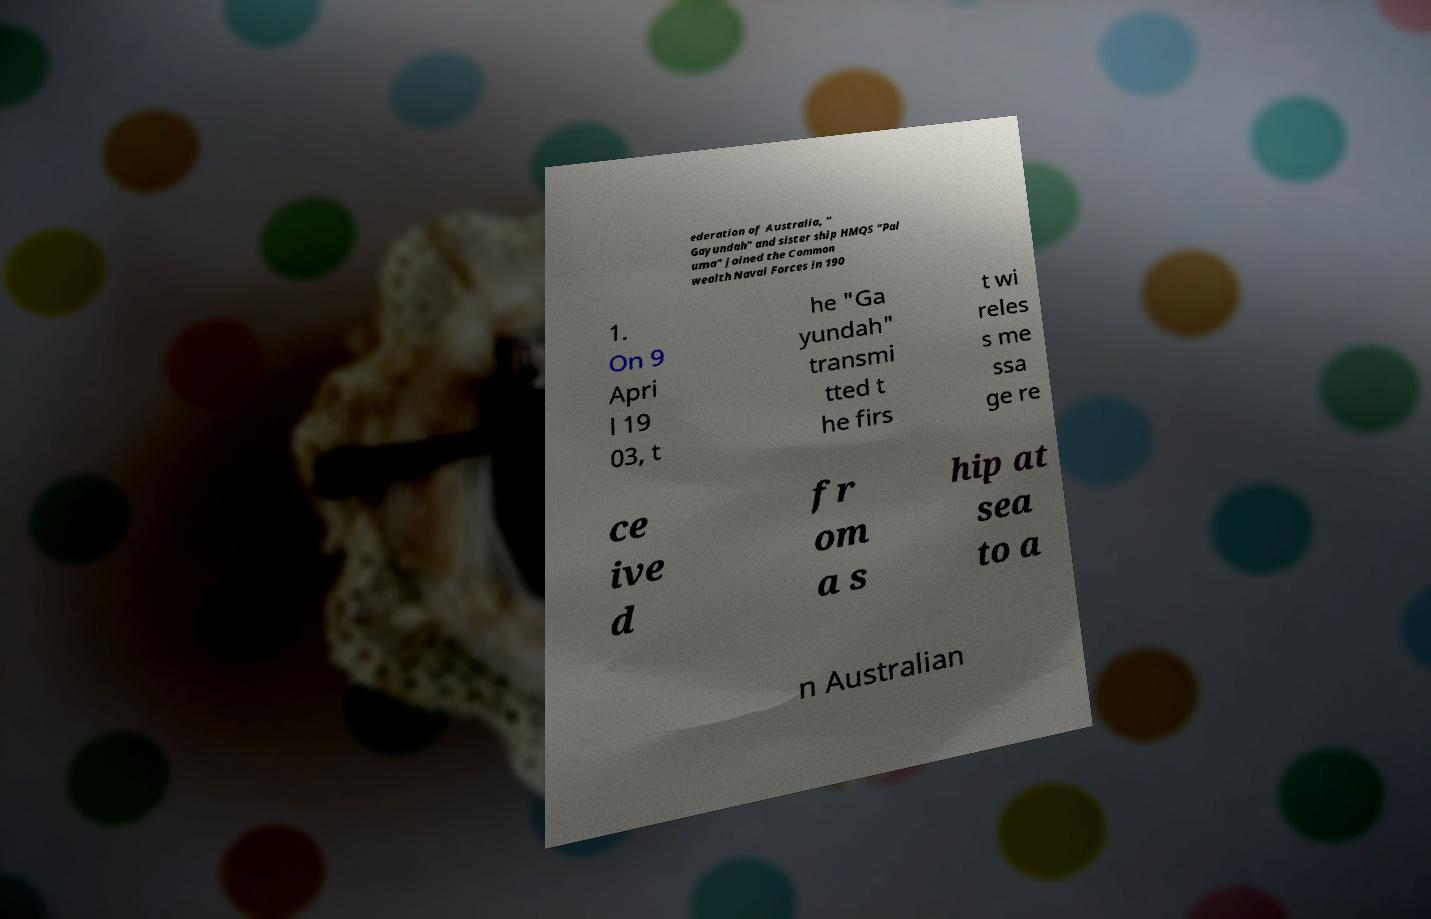There's text embedded in this image that I need extracted. Can you transcribe it verbatim? ederation of Australia, " Gayundah" and sister ship HMQS "Pal uma" joined the Common wealth Naval Forces in 190 1. On 9 Apri l 19 03, t he "Ga yundah" transmi tted t he firs t wi reles s me ssa ge re ce ive d fr om a s hip at sea to a n Australian 